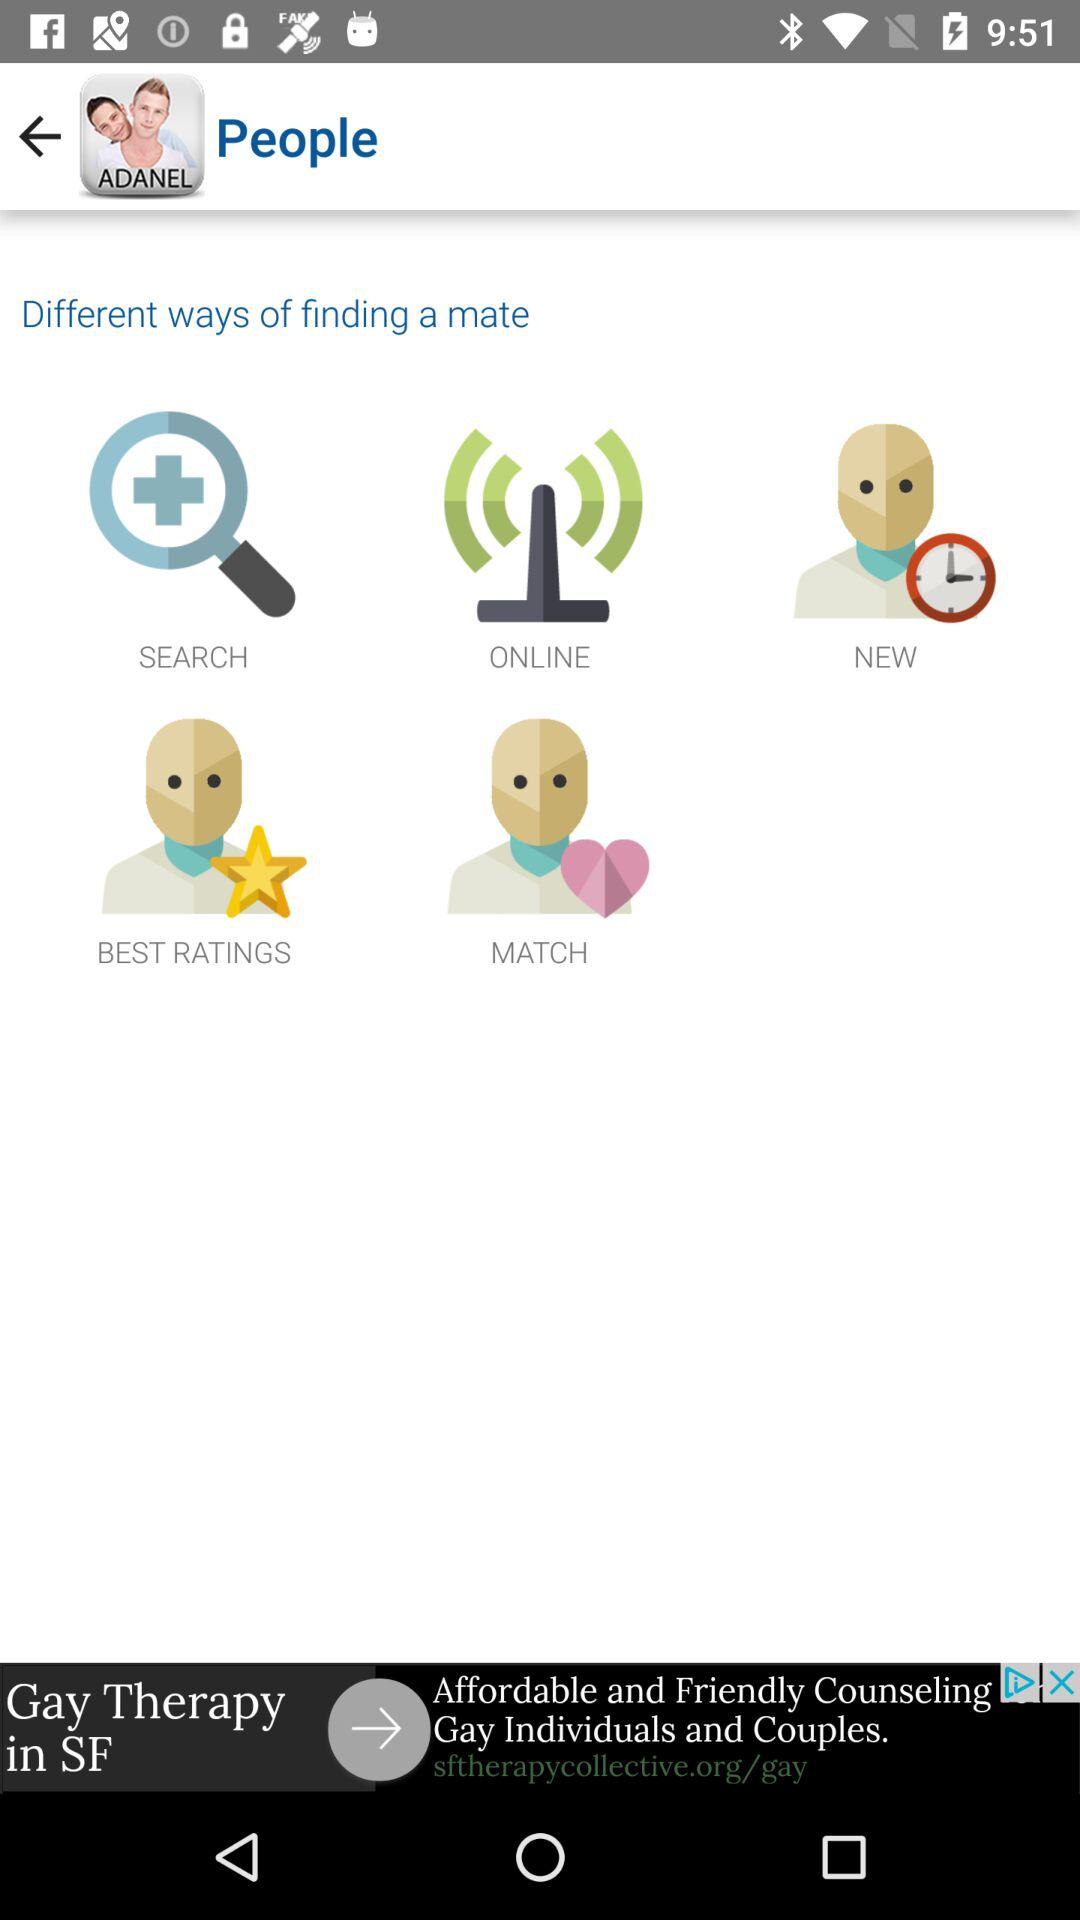What is the name of the application?
When the provided information is insufficient, respond with <no answer>. <no answer> 